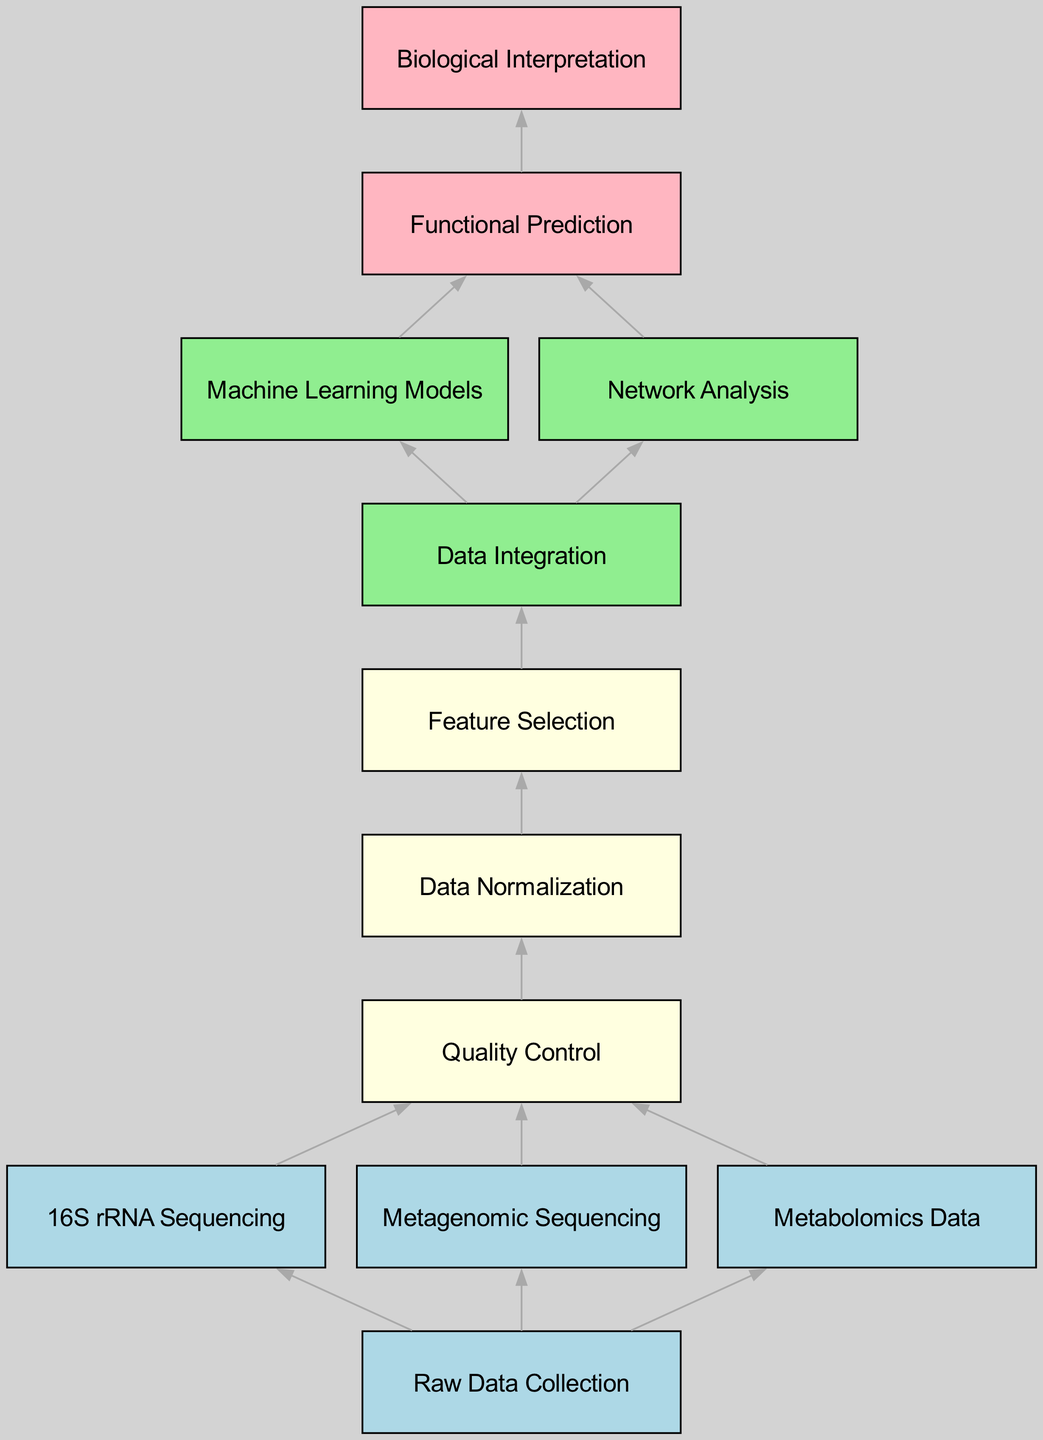What is the first step in the workflow? According to the diagram, the first step is represented by the node labeled "Raw Data Collection".
Answer: Raw Data Collection How many types of sequences are collected in the initial stage? From the diagram, there are three types of sequencing data collected in the initial stage: "16S rRNA Sequencing", "Metagenomic Sequencing", and "Metabolomics Data". Thus, the total is three.
Answer: 3 What follows Quality Control in the workflow? The node immediately after "Quality Control" is "Data Normalization", indicating the next step in the workflow.
Answer: Data Normalization How many edges connect the "Data Integration" node? The "Data Integration" node is connected by two edges, leading to "Machine Learning Models" and "Network Analysis".
Answer: 2 What is the relationship between "Machine Learning Models" and "Functional Prediction"? "Machine Learning Models" is upstream of "Functional Prediction"; meaning "Machine Learning Models" influences "Functional Prediction", as indicated by an edge connecting them.
Answer: Upstream Which node represents the conclusion of the workflow? The concluding node of the workflow is labeled "Biological Interpretation", as it is the final step shown in the diagram.
Answer: Biological Interpretation What is the color indicating nodes for data collection methods? The nodes representing data collection methods, such as "16S rRNA Sequencing", "Metagenomic Sequencing", and "Metabolomics Data", are colored light blue.
Answer: Light blue Identify the last step before "Biological Interpretation". The node just before "Biological Interpretation" is "Functional Prediction", making it the penultimate step in the workflow.
Answer: Functional Prediction How are "Network Analysis" and "Functional Prediction" connected? Both "Network Analysis" and "Machine Learning Models" lead into the "Functional Prediction" node, indicating they contribute to functional prediction activities.
Answer: Contribute 